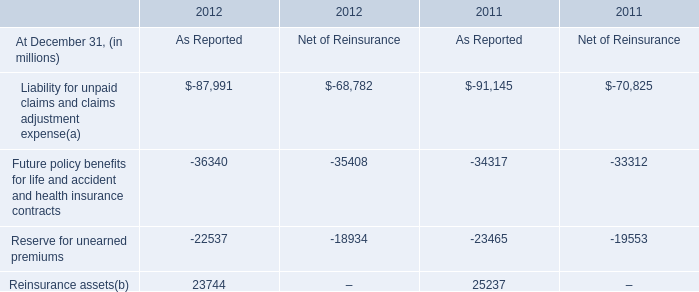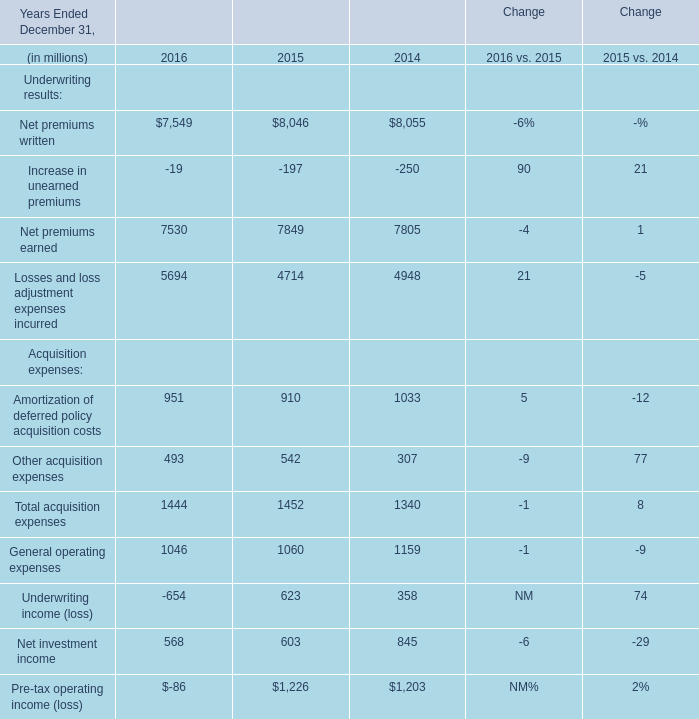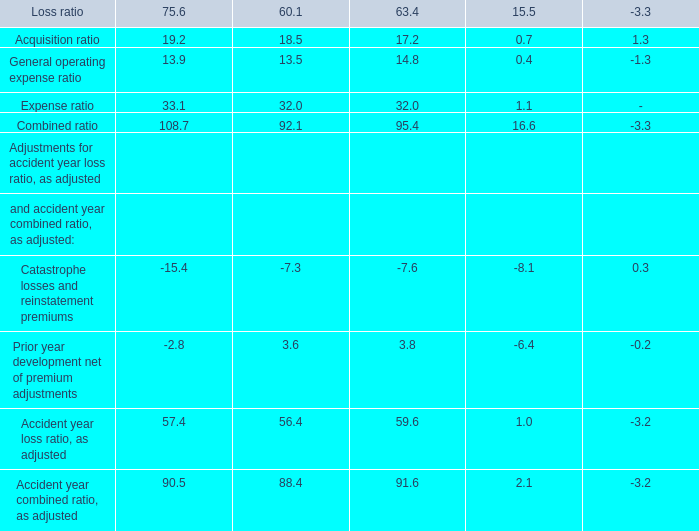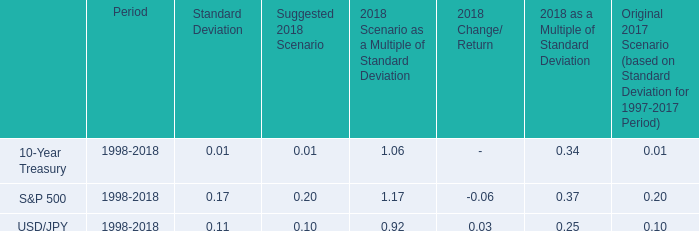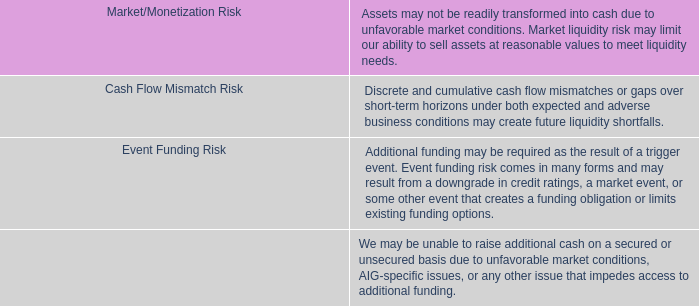of the recorded net asset balance of rio grande at december 1 , 2009 , what percentage was cash? 
Computations: (3.1 / 22.7)
Answer: 0.13656. 